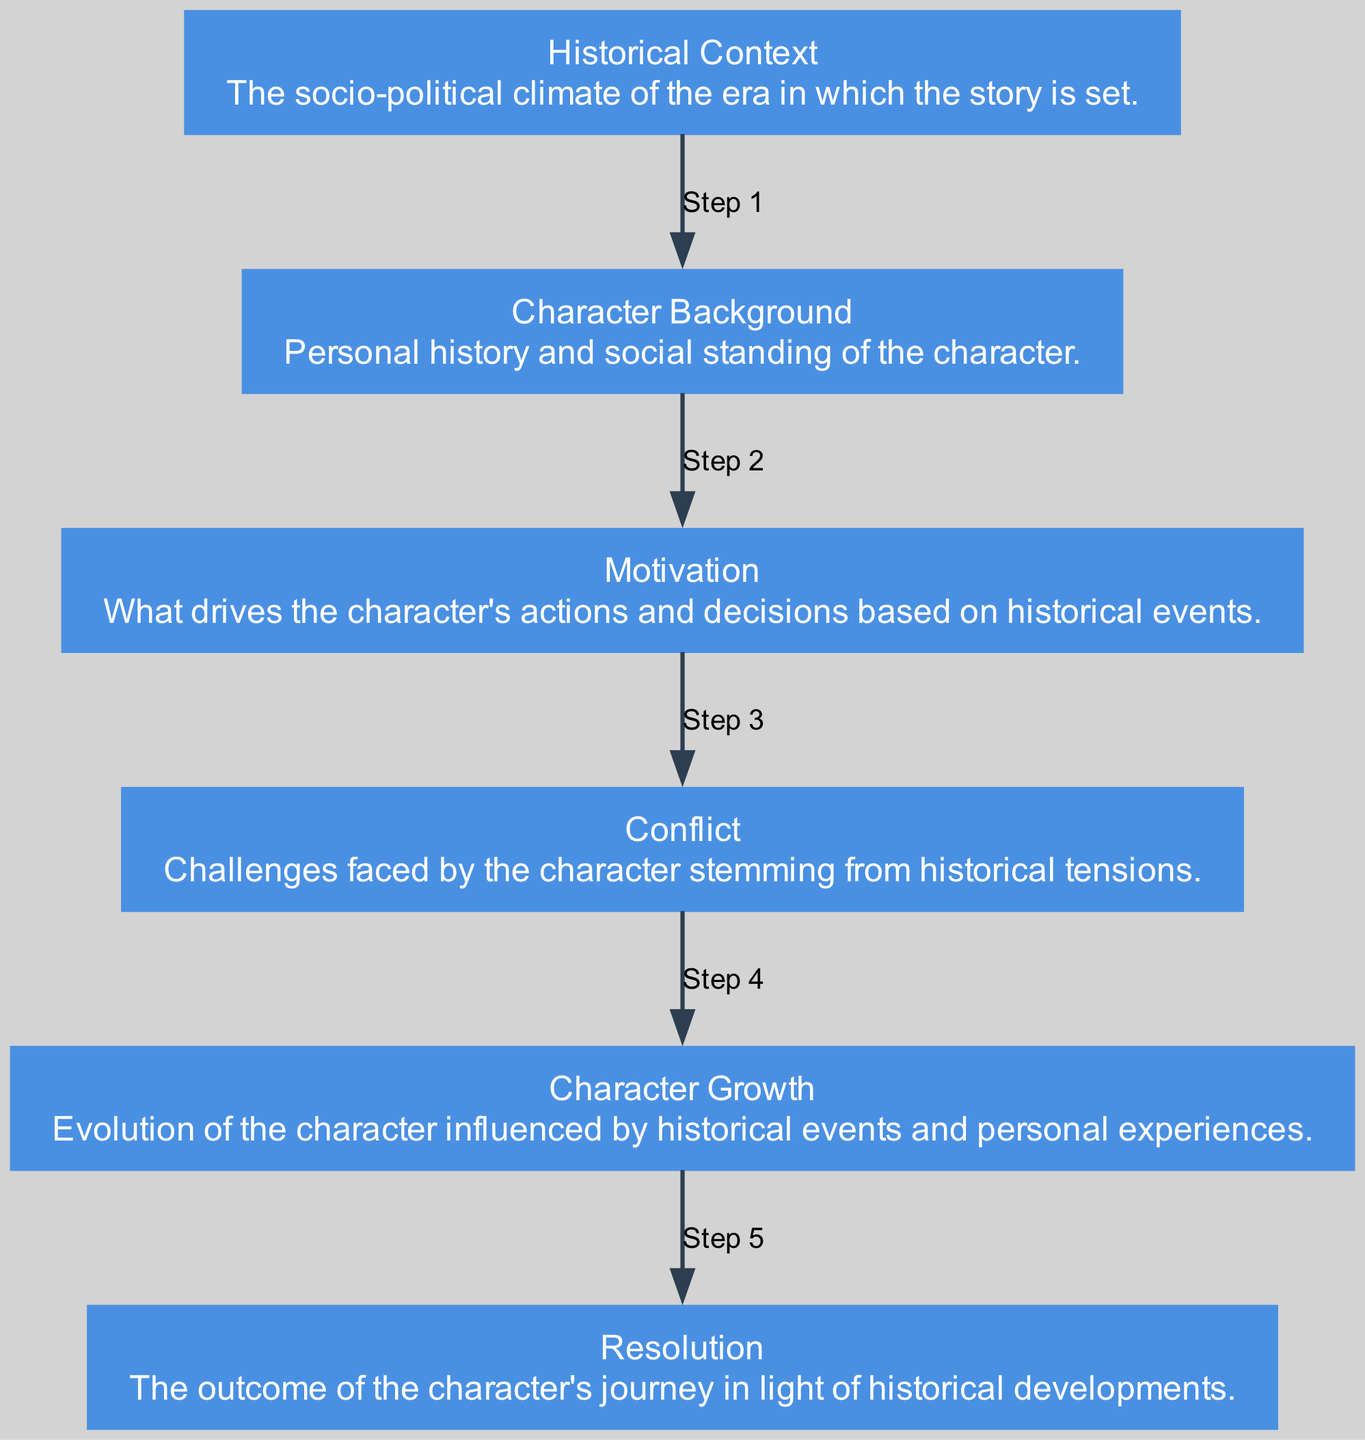what is the first element in the diagram? The first element listed in the diagram is "Historical Context," which is the starting point of the character development journey.
Answer: Historical Context how many elements are there in the diagram? By counting each unique element provided in the data, we note that there are six elements: Historical Context, Character Background, Motivation, Conflict, Character Growth, and Resolution.
Answer: 6 what is the description of the Character Growth node? The description associated with the Character Growth node reads, "Evolution of the character influenced by historical events and personal experiences," detailing how characters can change over time.
Answer: Evolution of the character influenced by historical events and personal experiences what is the relationship between Motivation and Conflict? The diagram indicates a sequential relationship where Motivation leads to Conflict, suggesting that the character's drive becomes the basis for the challenges they face stemming from historical tensions.
Answer: Motivation leads to Conflict which element follows Conflict in the sequence? Looking at the flow of the diagram, after Conflict, the next element is Character Growth, indicating a progression from facing challenges to personal evolution based on those experiences.
Answer: Character Growth how does the historical context influence character motivation? Historical Context shapes Character Background, which in turn informs the Character's Motivation, illustrating that the socio-political climate directly impacts the character’s desires and actions.
Answer: Historical Context shapes Character Motivation what is the final outcome of the character's journey as depicted in the diagram? The last element in the flow chart is Resolution, which signifies the conclusion or final outcome after the character has undergone their journey influenced by the historical developments.
Answer: Resolution what step follows Character Background? The diagram outlines that after Character Background comes Motivation, highlighting a logical sequence where a character's past informs their current drives and goals.
Answer: Motivation what role does Conflict play in the character development journey? Conflict acts as a crucial challenge faced by the character, arising from historical tensions, which is necessary for the evolution and growth of the character throughout the narrative.
Answer: Challenges faced by the character stemming from historical tensions 